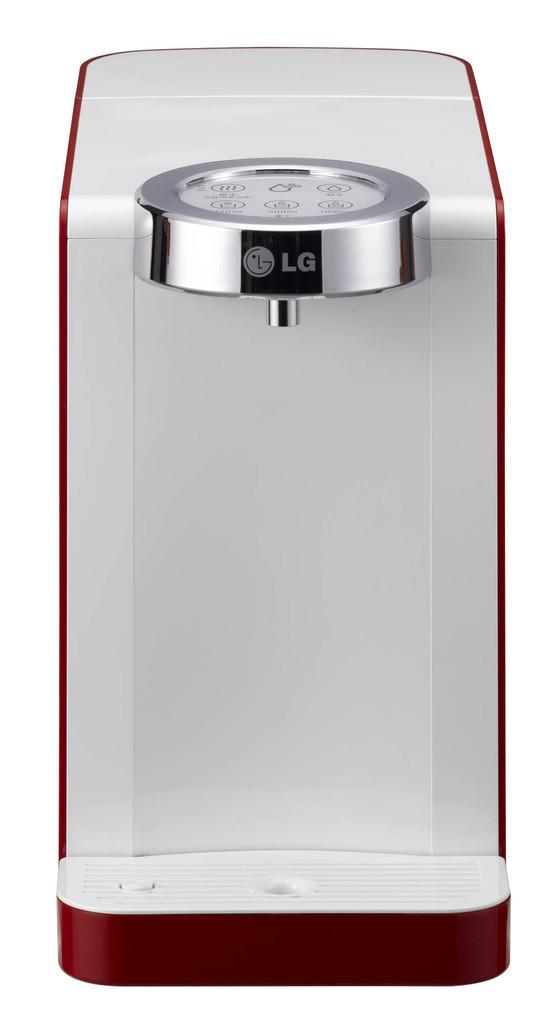What brand is featured?
Offer a terse response. Lg. 